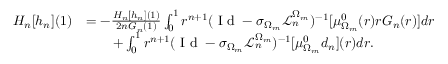<formula> <loc_0><loc_0><loc_500><loc_500>\begin{array} { r l } { H _ { n } [ h _ { n } ] ( 1 ) } & { = - \frac { H _ { n } [ h _ { n } ] ( 1 ) } { 2 n G _ { n } ( 1 ) } \int _ { 0 } ^ { 1 } r ^ { n + 1 } ( I d - \sigma _ { \Omega _ { m } } \mathcal { L } _ { n } ^ { \Omega _ { m } } ) ^ { - 1 } [ \mu _ { \Omega _ { m } } ^ { 0 } ( r ) r G _ { n } ( r ) ] d r } \\ & { \quad + \int _ { 0 } ^ { 1 } r ^ { n + 1 } ( I d - \sigma _ { \Omega _ { m } } \mathcal { L } _ { n } ^ { \Omega _ { m } } ) ^ { - 1 } [ \mu _ { \Omega _ { m } } ^ { 0 } d _ { n } ] ( r ) d r . } \end{array}</formula> 